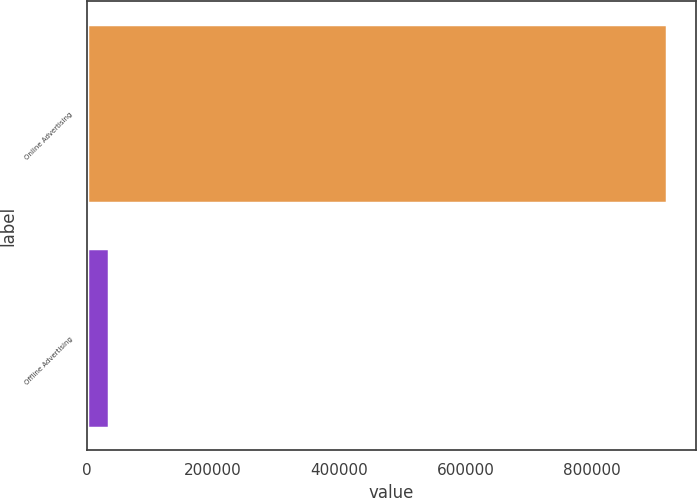<chart> <loc_0><loc_0><loc_500><loc_500><bar_chart><fcel>Online Advertising<fcel>Offline Advertising<nl><fcel>919214<fcel>35470<nl></chart> 